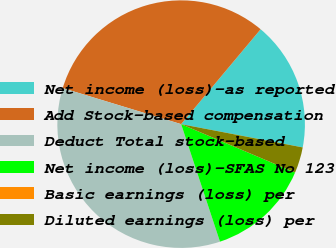Convert chart. <chart><loc_0><loc_0><loc_500><loc_500><pie_chart><fcel>Net income (loss)-as reported<fcel>Add Stock-based compensation<fcel>Deduct Total stock-based<fcel>Net income (loss)-SFAS No 123<fcel>Basic earnings (loss) per<fcel>Diluted earnings (loss) per<nl><fcel>16.91%<fcel>31.4%<fcel>34.78%<fcel>13.53%<fcel>0.0%<fcel>3.38%<nl></chart> 